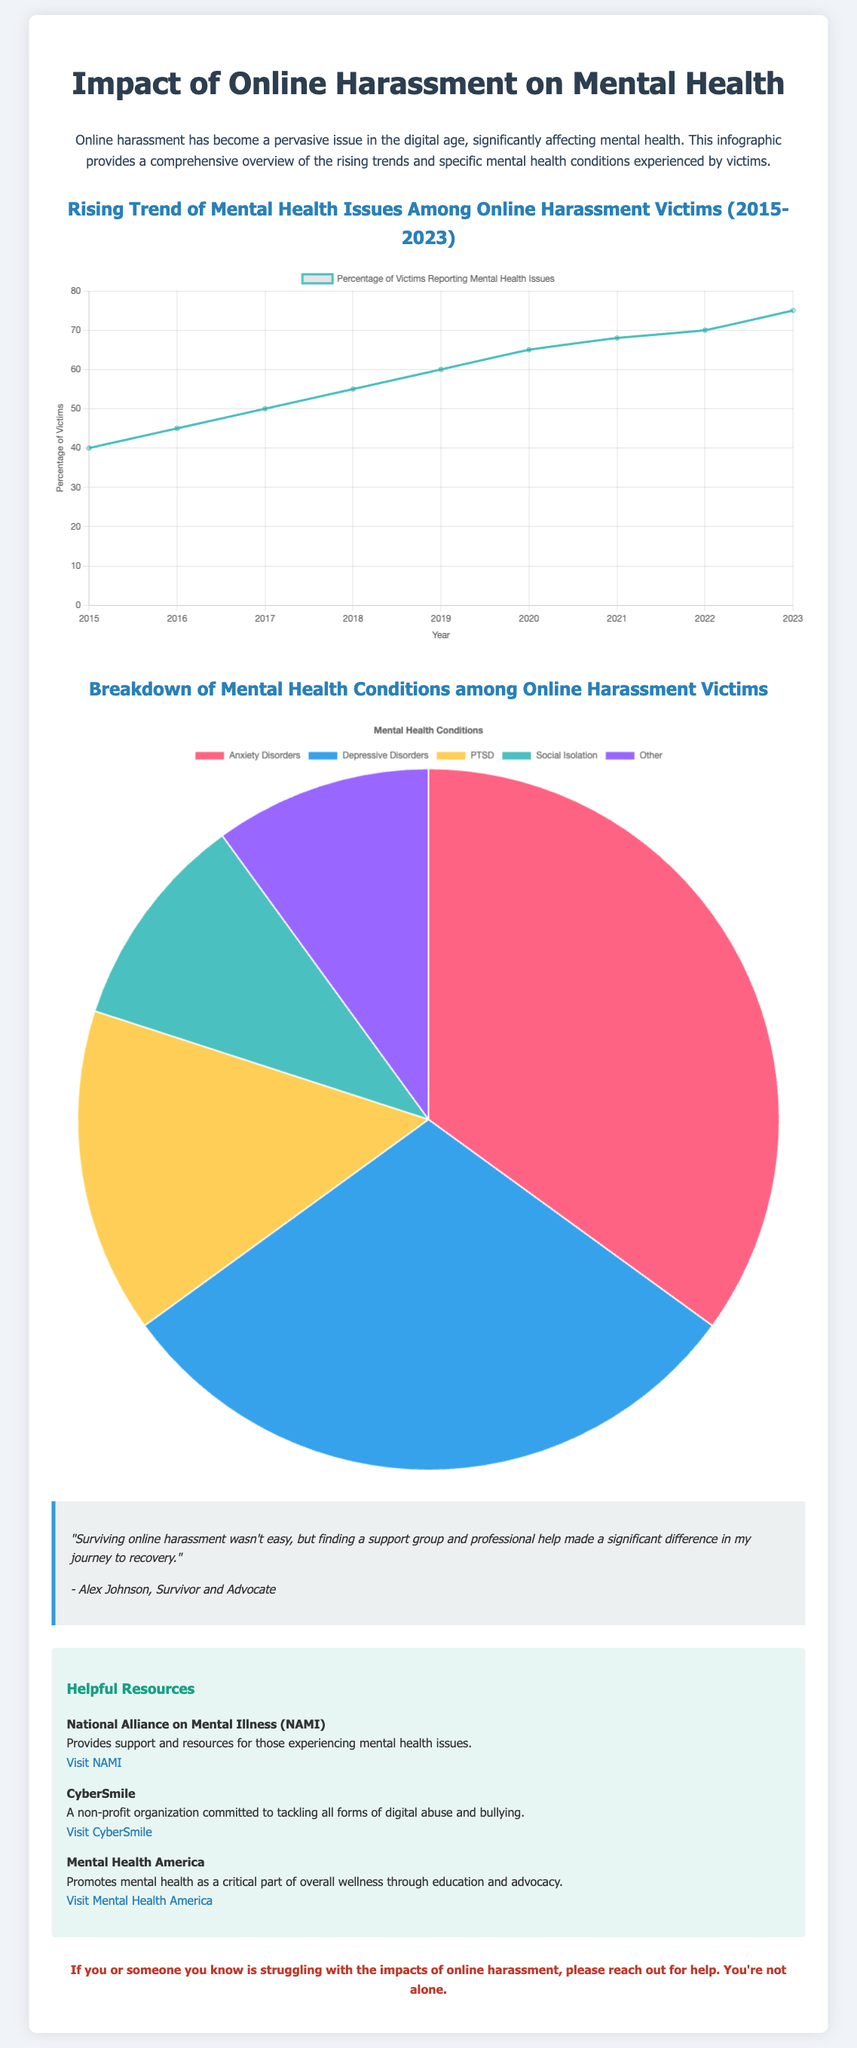What is the title of the infographic? The title of the infographic is prominently displayed at the top of the document, which is related to mental health and online harassment.
Answer: Impact of Online Harassment on Mental Health What years are represented in the line chart? The line chart covers the years from 2015 to 2023, as indicated by the labels on the x-axis.
Answer: 2015 to 2023 What percentage of victims reported mental health issues in 2023? The data point for 2023 in the line chart shows the percentage of victims reporting mental health issues.
Answer: 75 What is the largest mental health condition reported among victims? The pie chart indicates the breakdown of mental health conditions, showing the largest portion of the data.
Answer: Anxiety Disorders How many types of conditions are represented in the pie chart? The pie chart lists the different mental health conditions experienced by victims of online harassment.
Answer: 5 What type of organization is CyberSmile? The document describes CyberSmile's role in addressing digital abuse and bullying.
Answer: Non-profit What color represents PTSD in the pie chart? The answer can be found by observing the color scheme used for the various conditions in the pie chart.
Answer: Yellow What message is conveyed at the end of the document? The closing message summarizes the document's purpose and provides encouragement and support to those affected.
Answer: You're not alone 